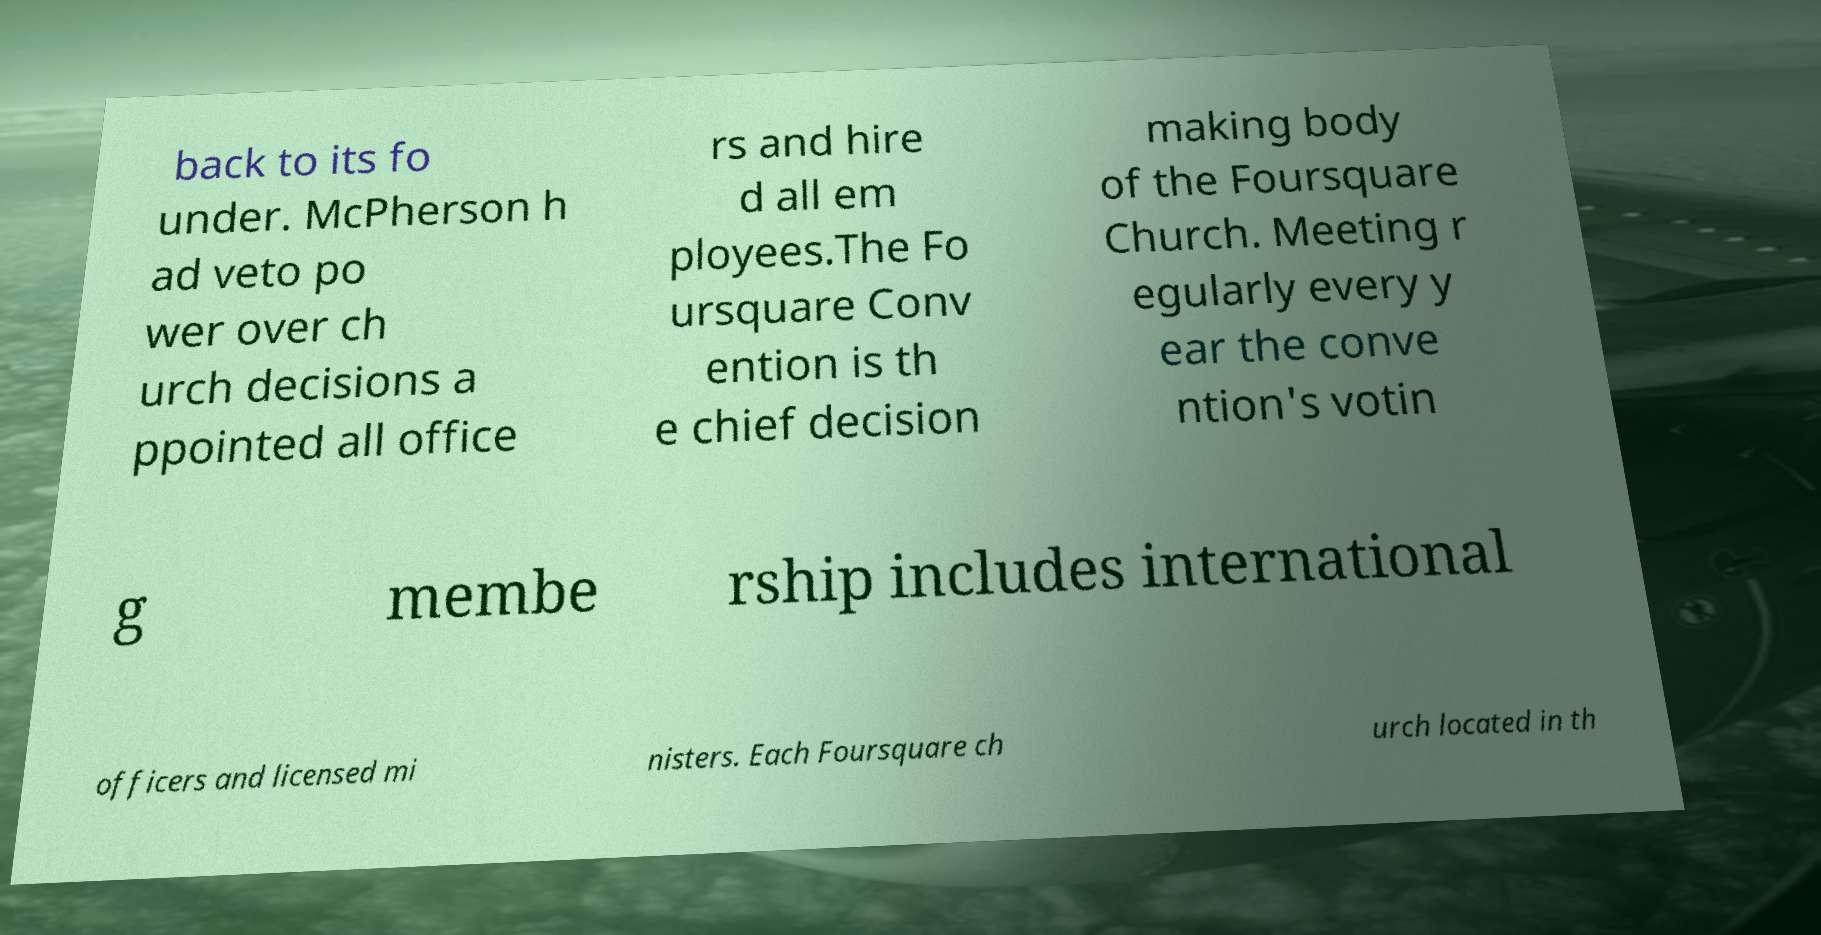What messages or text are displayed in this image? I need them in a readable, typed format. back to its fo under. McPherson h ad veto po wer over ch urch decisions a ppointed all office rs and hire d all em ployees.The Fo ursquare Conv ention is th e chief decision making body of the Foursquare Church. Meeting r egularly every y ear the conve ntion's votin g membe rship includes international officers and licensed mi nisters. Each Foursquare ch urch located in th 